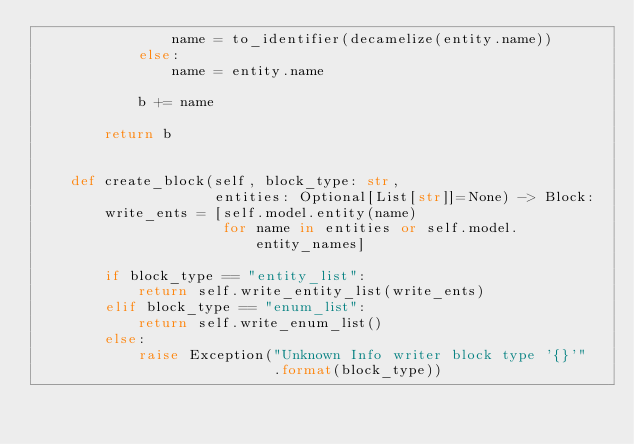<code> <loc_0><loc_0><loc_500><loc_500><_Python_>                name = to_identifier(decamelize(entity.name))
            else:
                name = entity.name

            b += name

        return b


    def create_block(self, block_type: str,
                     entities: Optional[List[str]]=None) -> Block:
        write_ents = [self.model.entity(name)
                      for name in entities or self.model.entity_names]

        if block_type == "entity_list":
            return self.write_entity_list(write_ents)
        elif block_type == "enum_list":
            return self.write_enum_list()
        else:
            raise Exception("Unknown Info writer block type '{}'"
                            .format(block_type))
</code> 